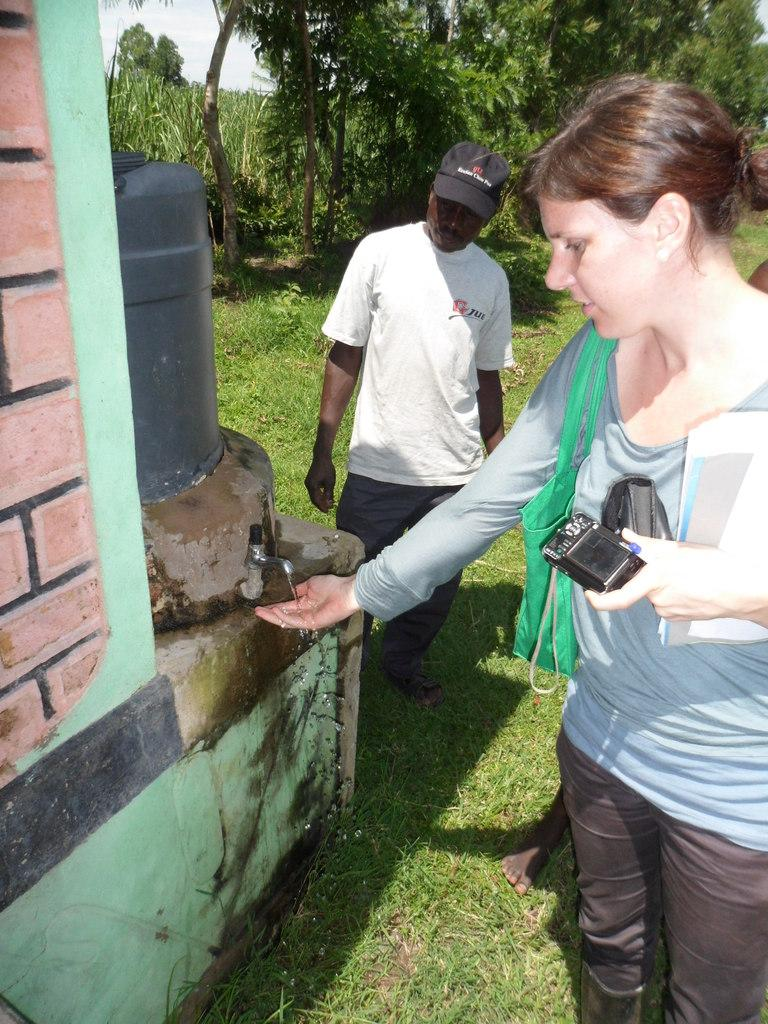How many people are in the image? There are people in the image, but the exact number is not specified. What is the primary structure in the image? There is a wall in the image. What is the source of water in the image? There is a tap in the image. What is the water stored in? There is a water tank in the image. What type of vegetation is present in the image? There is grass in the image. What can be seen in the background of the image? There are trees and the sky visible in the background of the image. Where is the hen located in the image? There is no hen present in the image. What type of test is being conducted in the image? There is no test being conducted in the image. 